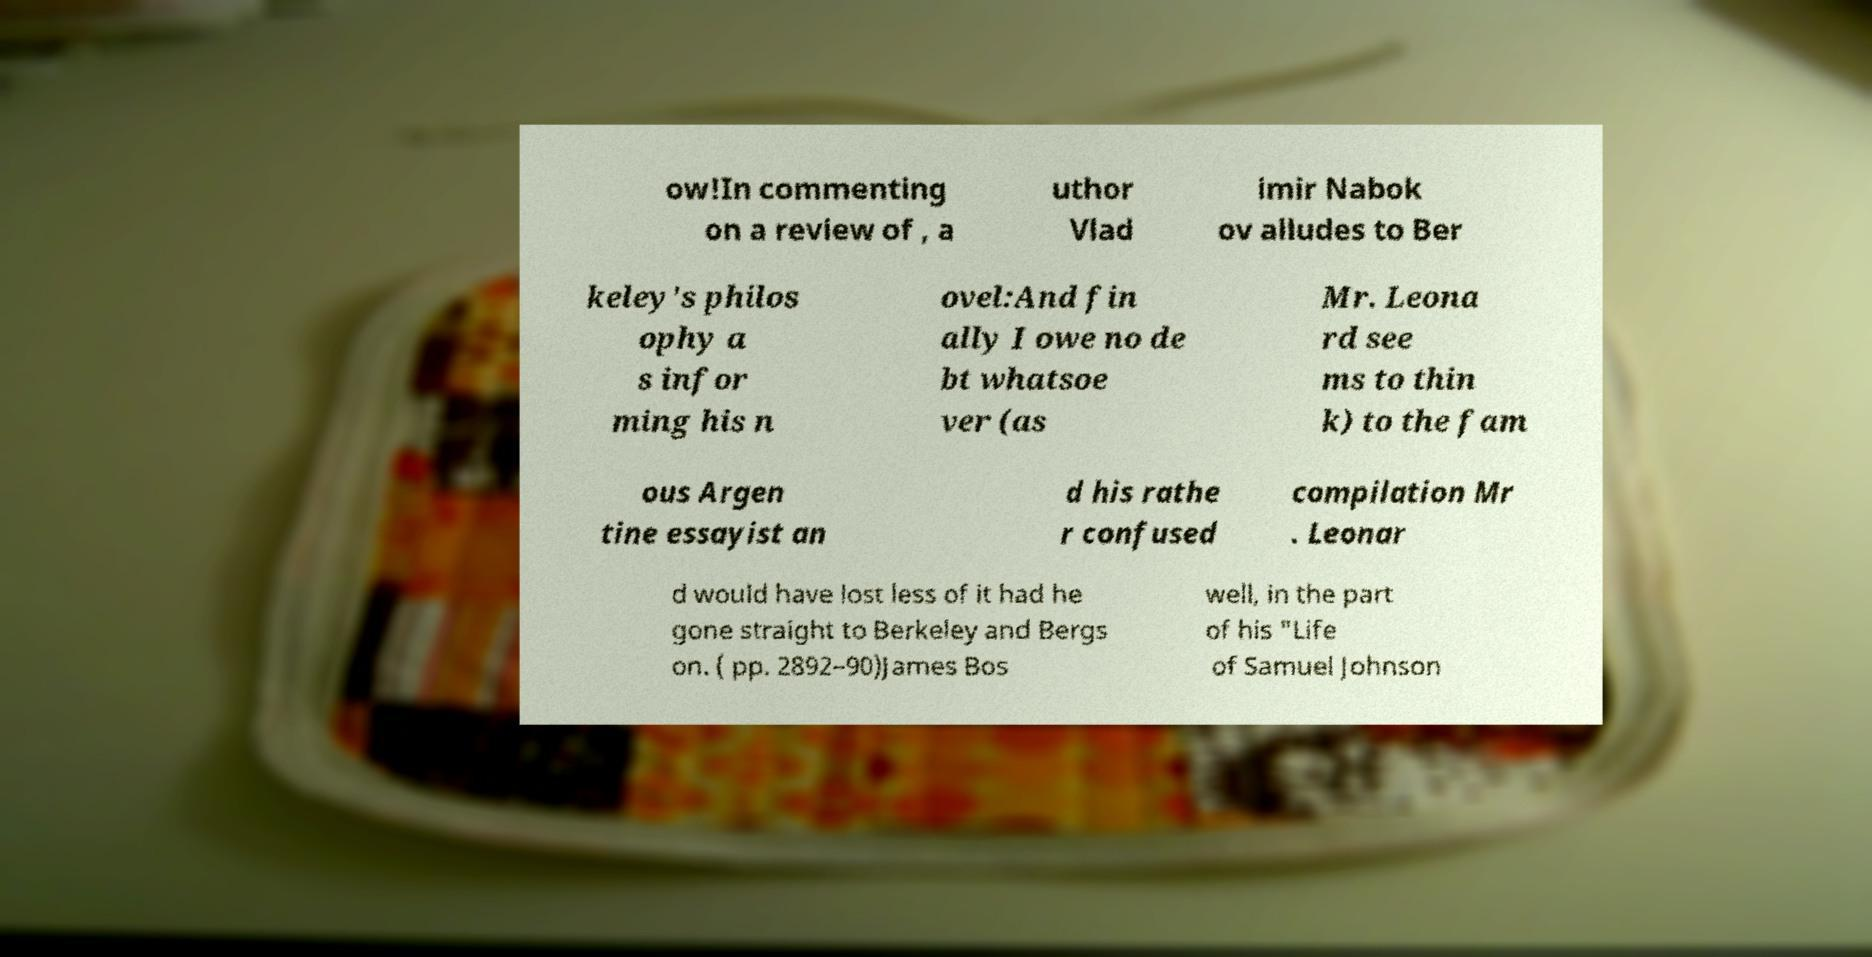Please read and relay the text visible in this image. What does it say? ow!In commenting on a review of , a uthor Vlad imir Nabok ov alludes to Ber keley's philos ophy a s infor ming his n ovel:And fin ally I owe no de bt whatsoe ver (as Mr. Leona rd see ms to thin k) to the fam ous Argen tine essayist an d his rathe r confused compilation Mr . Leonar d would have lost less of it had he gone straight to Berkeley and Bergs on. ( pp. 2892–90)James Bos well, in the part of his "Life of Samuel Johnson 